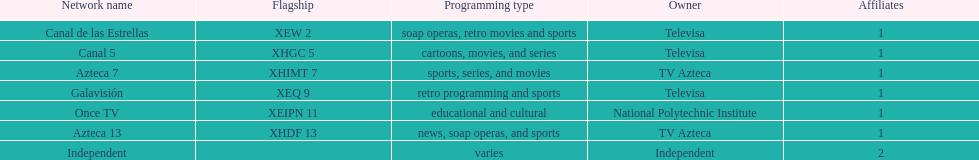Who are the proprietors of the stations in this list? Televisa, Televisa, TV Azteca, Televisa, National Polytechnic Institute, TV Azteca, Independent. Which single station belongs to the national polytechnic institute? Once TV. 